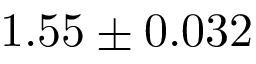Convert formula to latex. <formula><loc_0><loc_0><loc_500><loc_500>1 . 5 5 \pm 0 . 0 3 2</formula> 